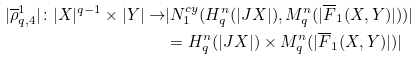Convert formula to latex. <formula><loc_0><loc_0><loc_500><loc_500>| \overline { \rho } ^ { 1 } _ { q , 4 } | \colon | X | ^ { q - 1 } \times | Y | \to & | N ^ { c y } _ { 1 } ( H ^ { n } _ { q } ( | J X | ) , M ^ { n } _ { q } ( | \overline { F } _ { 1 } ( X , Y ) | ) ) | \\ & = H ^ { n } _ { q } ( | J X | ) \times M ^ { n } _ { q } ( | \overline { F } _ { 1 } ( X , Y ) | ) |</formula> 